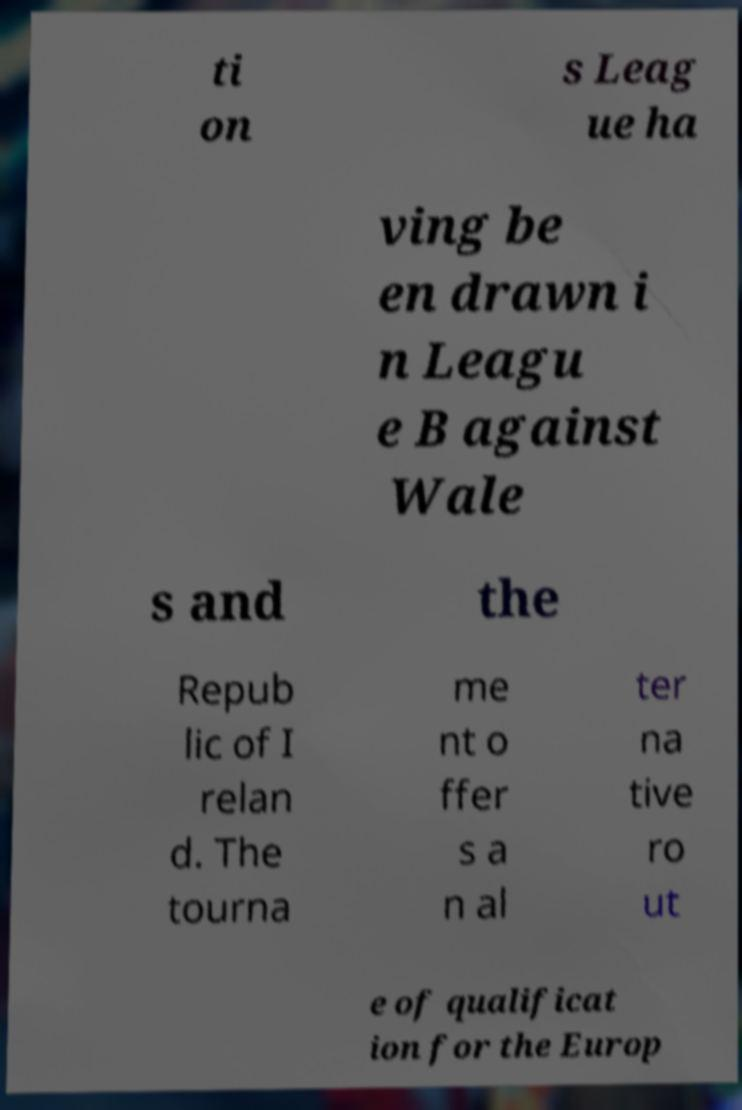Could you assist in decoding the text presented in this image and type it out clearly? ti on s Leag ue ha ving be en drawn i n Leagu e B against Wale s and the Repub lic of I relan d. The tourna me nt o ffer s a n al ter na tive ro ut e of qualificat ion for the Europ 